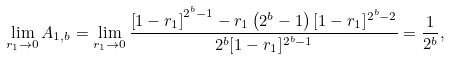Convert formula to latex. <formula><loc_0><loc_0><loc_500><loc_500>\lim _ { r _ { 1 } \rightarrow 0 } A _ { 1 , b } = \lim _ { r _ { 1 } \rightarrow 0 } \frac { \left [ 1 - r _ { 1 } \right ] ^ { 2 ^ { b } - 1 } - r _ { 1 } \left ( 2 ^ { b } - 1 \right ) [ 1 - r _ { 1 } ] ^ { 2 ^ { b } - 2 } } { 2 ^ { b } [ 1 - r _ { 1 } ] ^ { 2 ^ { b } - 1 } } = \frac { 1 } { 2 ^ { b } } ,</formula> 